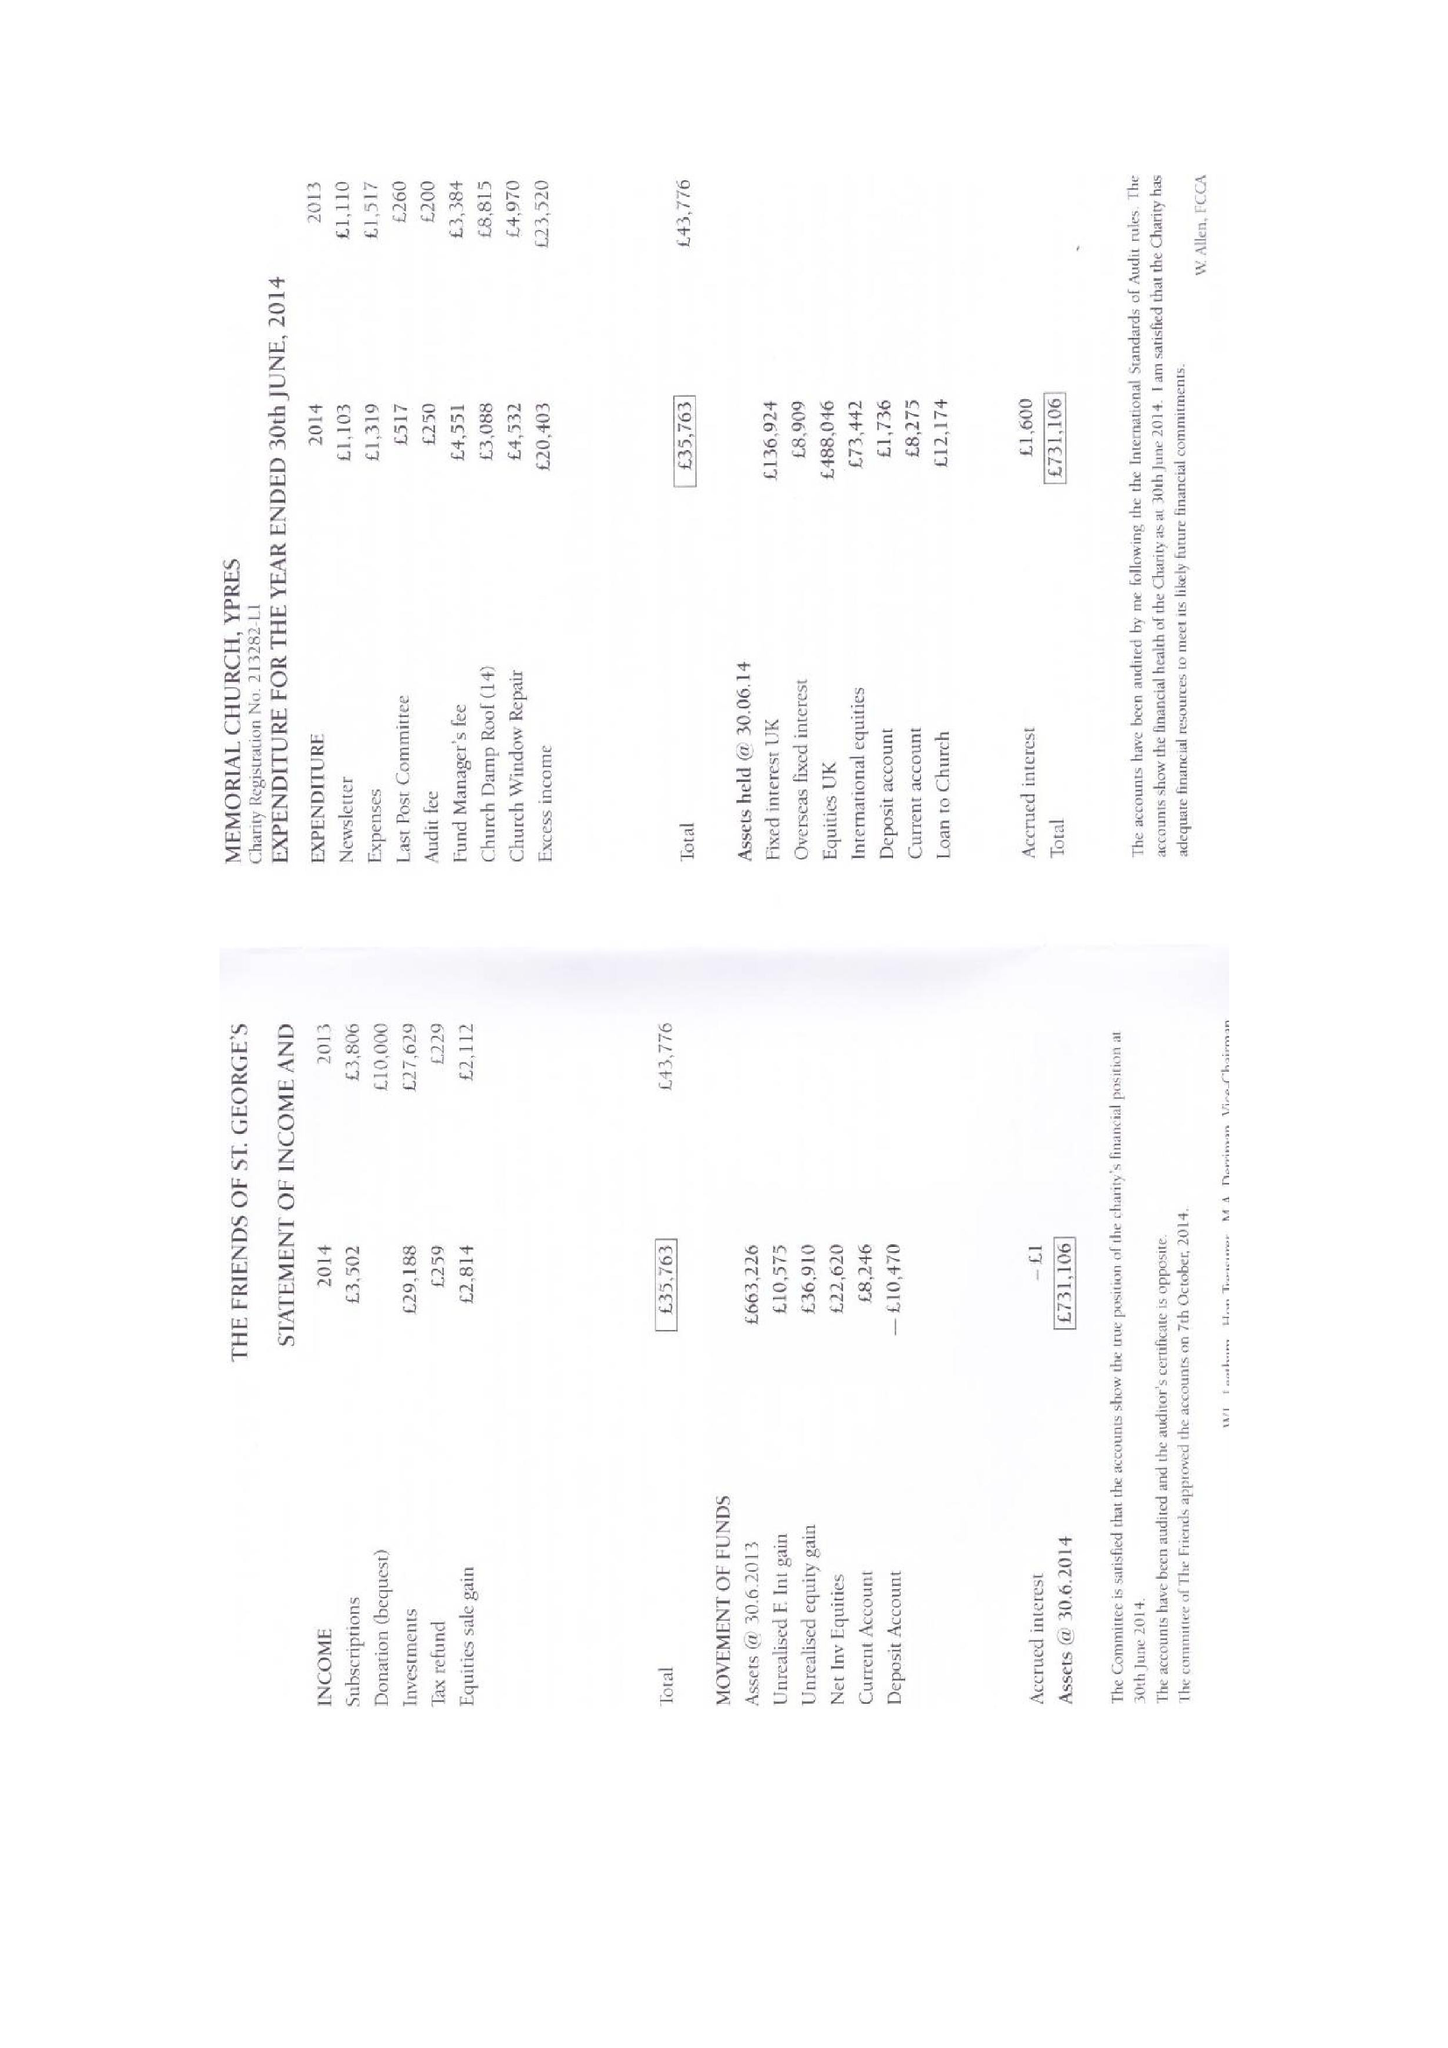What is the value for the address__street_line?
Answer the question using a single word or phrase. 69 HONEY HILL 